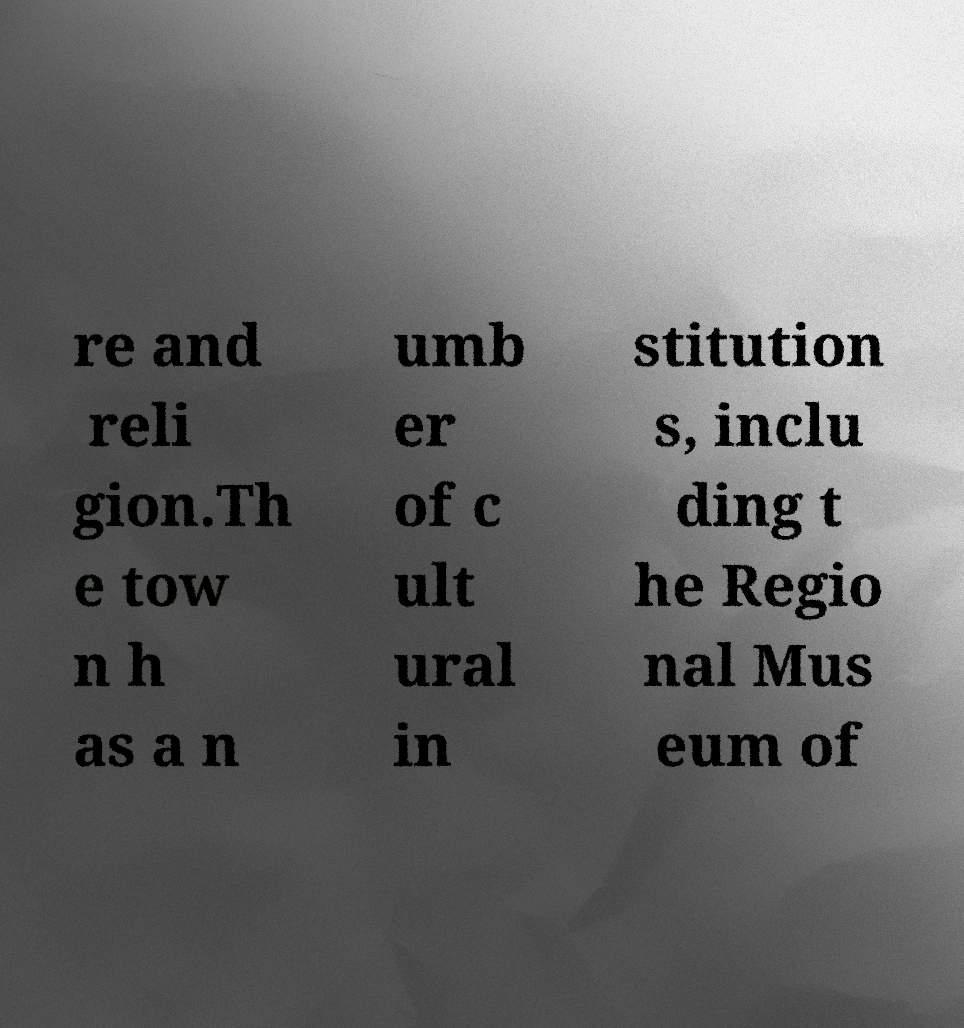Can you read and provide the text displayed in the image?This photo seems to have some interesting text. Can you extract and type it out for me? re and reli gion.Th e tow n h as a n umb er of c ult ural in stitution s, inclu ding t he Regio nal Mus eum of 